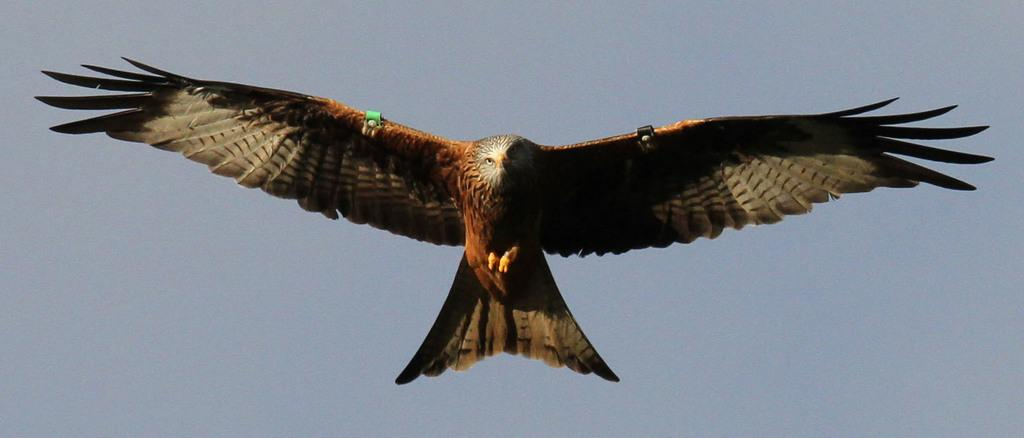What animal is in the foreground of the image? There is an owl in the foreground of the image. What can be seen in the background of the image? The sky is visible in the background of the image. Can you determine the time of day the image was taken? The image was likely taken during the day, as the sky is visible and not dark. What is the price of the grass in the image? There is no grass present in the image, so it is not possible to determine the price of any grass. 